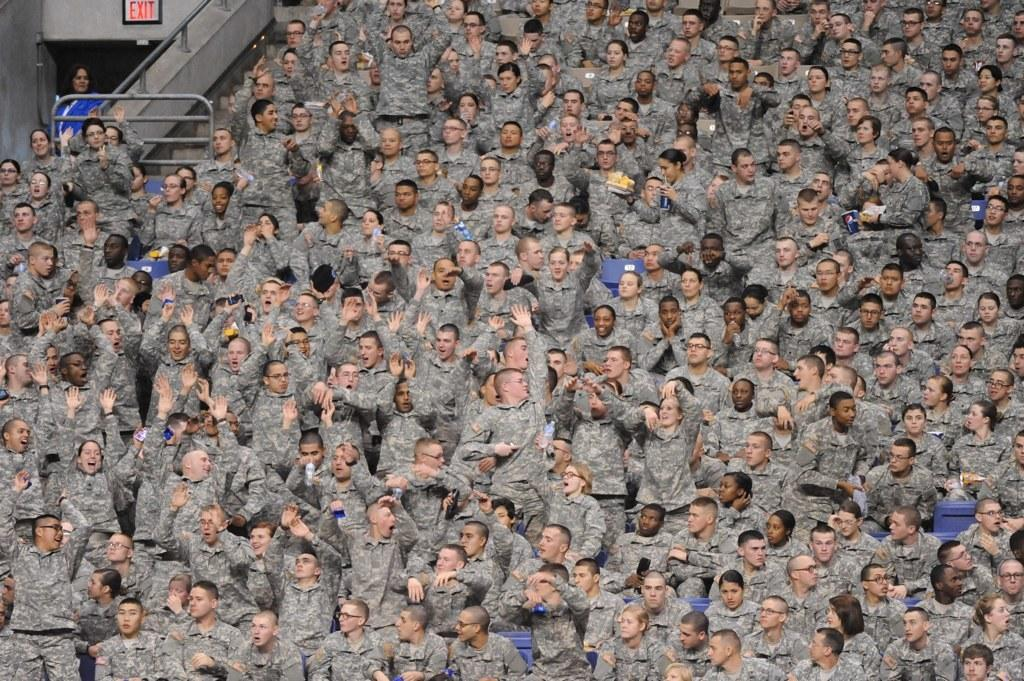How many people are visible in the image? There are many people in the image. What are the people doing in the image? The people are sitting on the stairs. Where are the stairs located in the image? The stairs are part of a stadium. What type of health issues are the people experiencing while sitting on the stairs? There is no indication of any health issues in the image; the people are simply sitting on the stairs. 